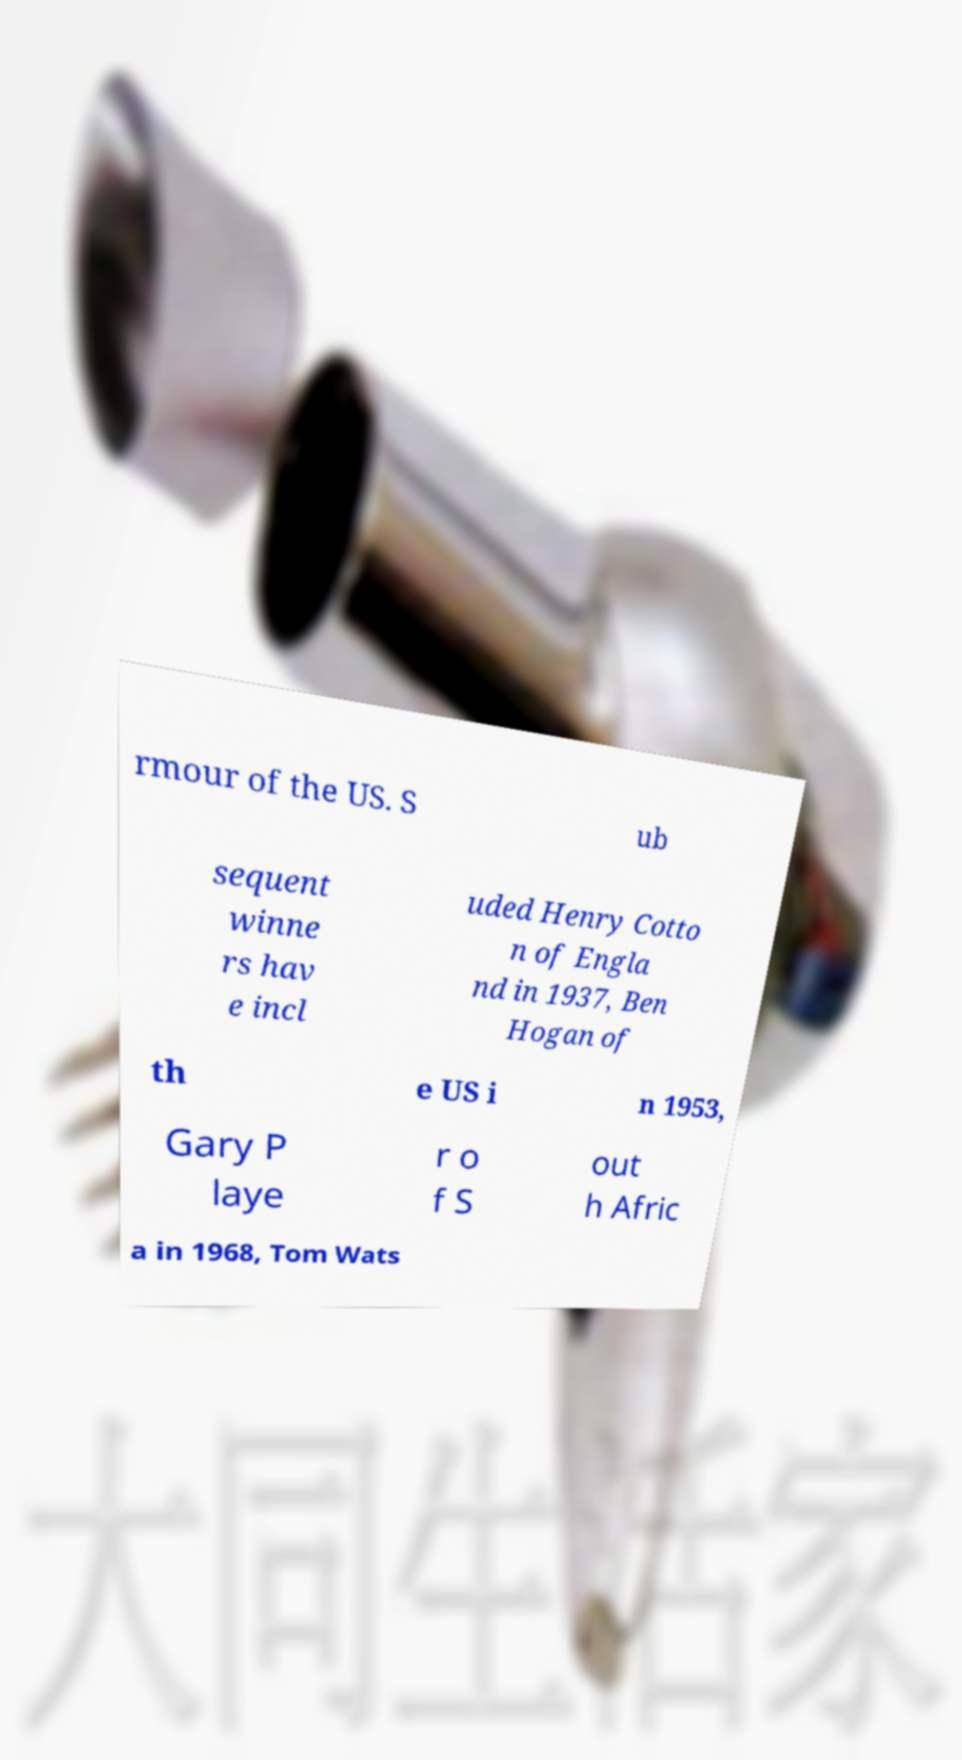Can you read and provide the text displayed in the image?This photo seems to have some interesting text. Can you extract and type it out for me? rmour of the US. S ub sequent winne rs hav e incl uded Henry Cotto n of Engla nd in 1937, Ben Hogan of th e US i n 1953, Gary P laye r o f S out h Afric a in 1968, Tom Wats 